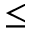Convert formula to latex. <formula><loc_0><loc_0><loc_500><loc_500>\leq</formula> 